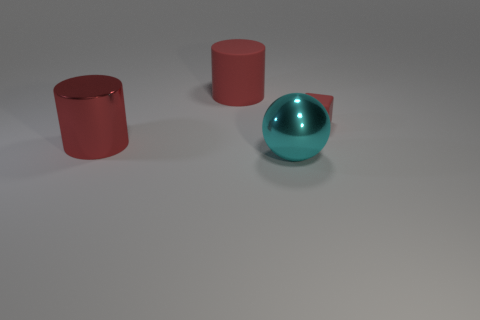Are there any other things that have the same size as the rubber cube?
Offer a very short reply. No. What is the color of the big object that is both in front of the tiny object and to the left of the cyan object?
Your response must be concise. Red. What number of shiny cylinders have the same color as the big rubber cylinder?
Give a very brief answer. 1. What number of cylinders are red shiny objects or rubber objects?
Ensure brevity in your answer.  2. There is a metal sphere that is the same size as the red metallic object; what is its color?
Make the answer very short. Cyan. There is a red cylinder that is on the right side of the cylinder that is in front of the tiny rubber thing; are there any big objects that are right of it?
Provide a succinct answer. Yes. What is the size of the red metallic cylinder?
Your response must be concise. Large. What number of objects are either metallic cylinders or big purple matte spheres?
Keep it short and to the point. 1. What is the color of the big thing that is made of the same material as the tiny thing?
Your response must be concise. Red. Does the matte thing in front of the red matte cylinder have the same shape as the big rubber object?
Give a very brief answer. No. 